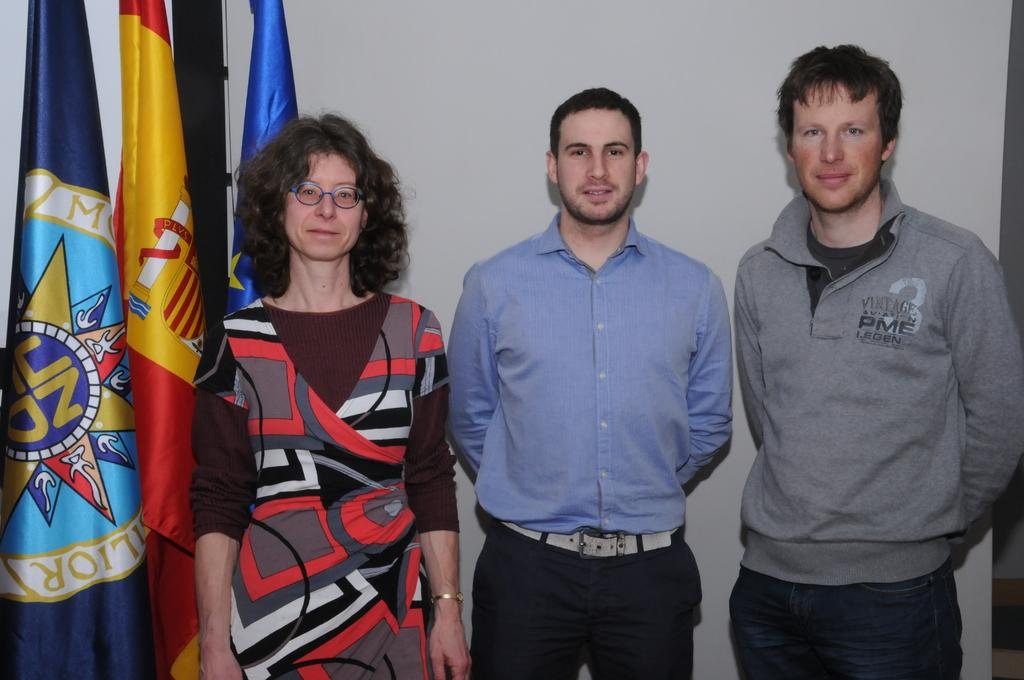How many people are in the image? There are three persons in the image. Can you describe the gender of the people in the image? One of the persons is a woman, and the other two are men. What can be seen on the left side of the image? There are flags on the left side of the image. What type of ornament is the woman wearing on her head in the image? There is no ornament visible on the woman's head in the image. 